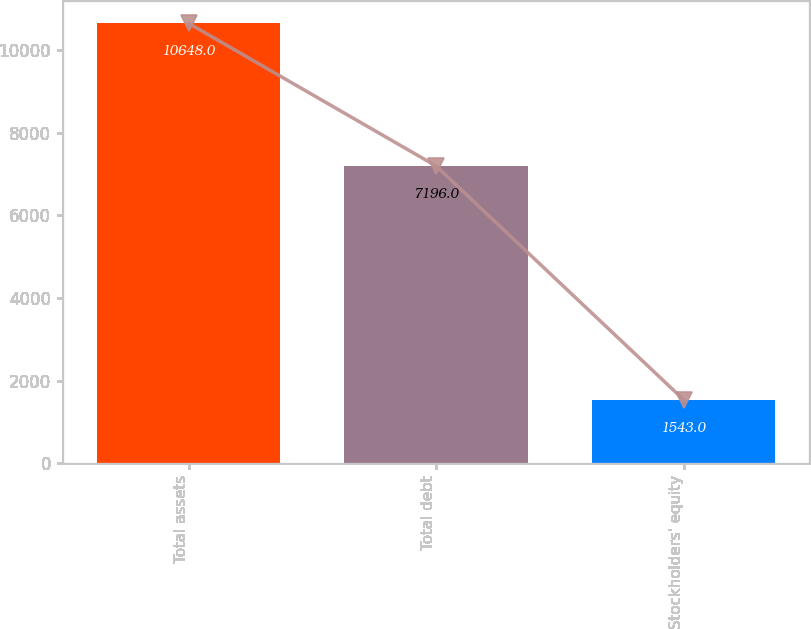Convert chart to OTSL. <chart><loc_0><loc_0><loc_500><loc_500><bar_chart><fcel>Total assets<fcel>Total debt<fcel>Stockholders' equity<nl><fcel>10648<fcel>7196<fcel>1543<nl></chart> 